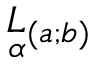Convert formula to latex. <formula><loc_0><loc_0><loc_500><loc_500>\underset { \alpha } { L _ { ( a ; b ) }</formula> 